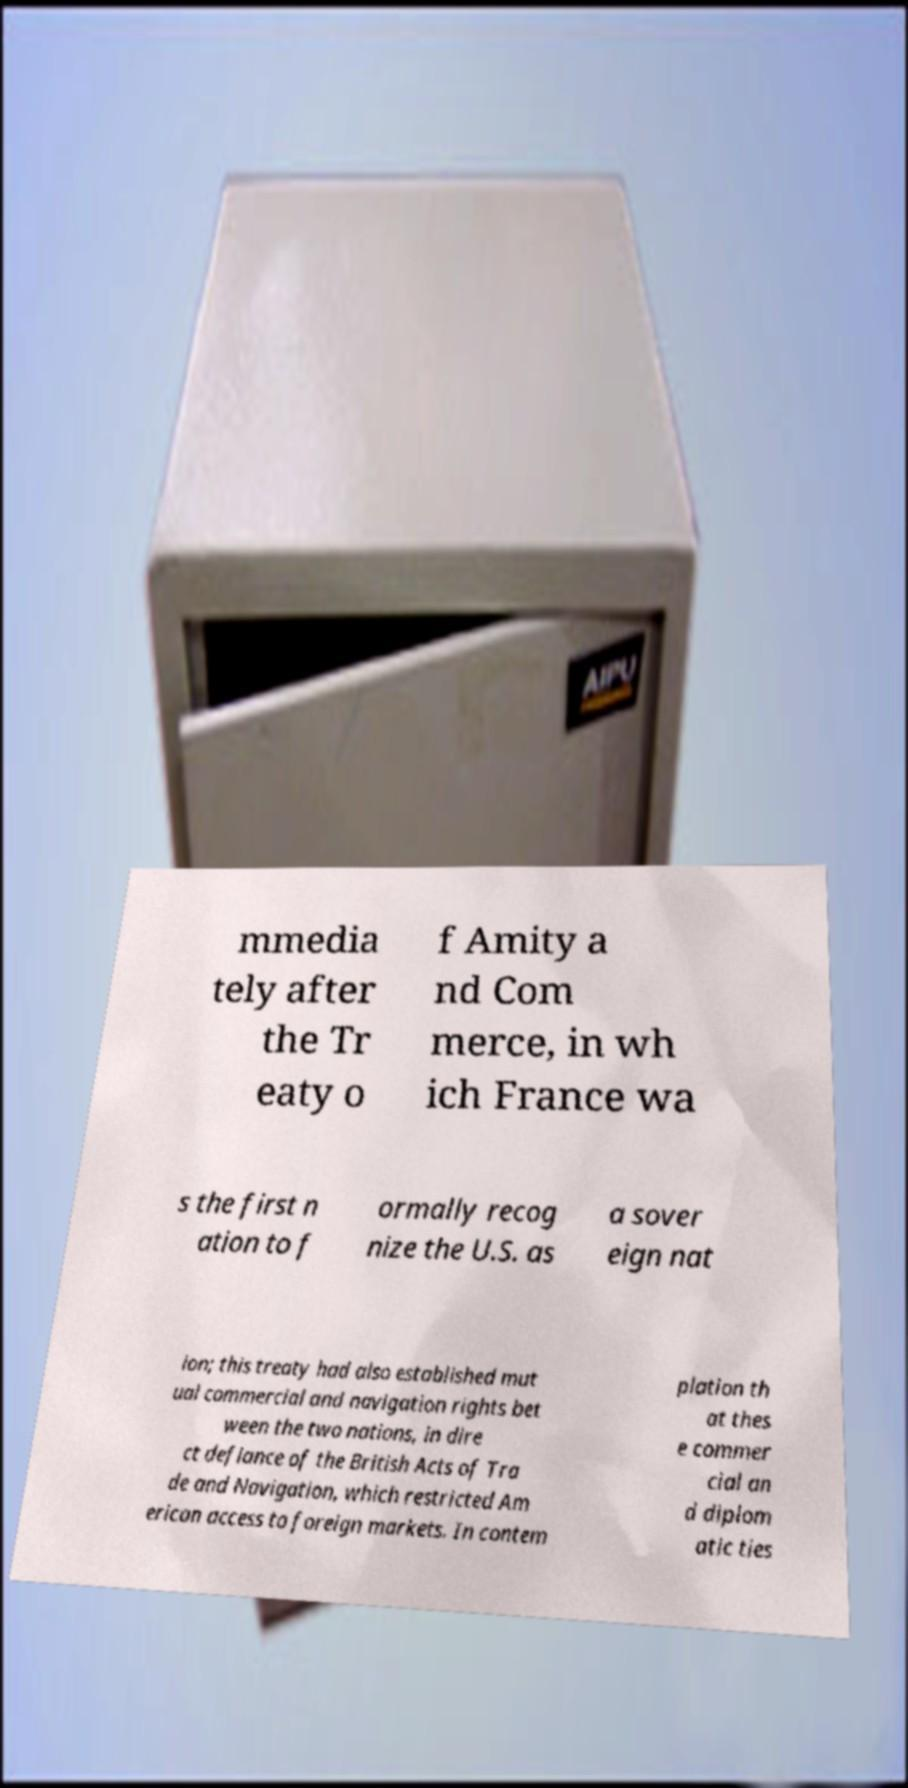Please identify and transcribe the text found in this image. mmedia tely after the Tr eaty o f Amity a nd Com merce, in wh ich France wa s the first n ation to f ormally recog nize the U.S. as a sover eign nat ion; this treaty had also established mut ual commercial and navigation rights bet ween the two nations, in dire ct defiance of the British Acts of Tra de and Navigation, which restricted Am erican access to foreign markets. In contem plation th at thes e commer cial an d diplom atic ties 